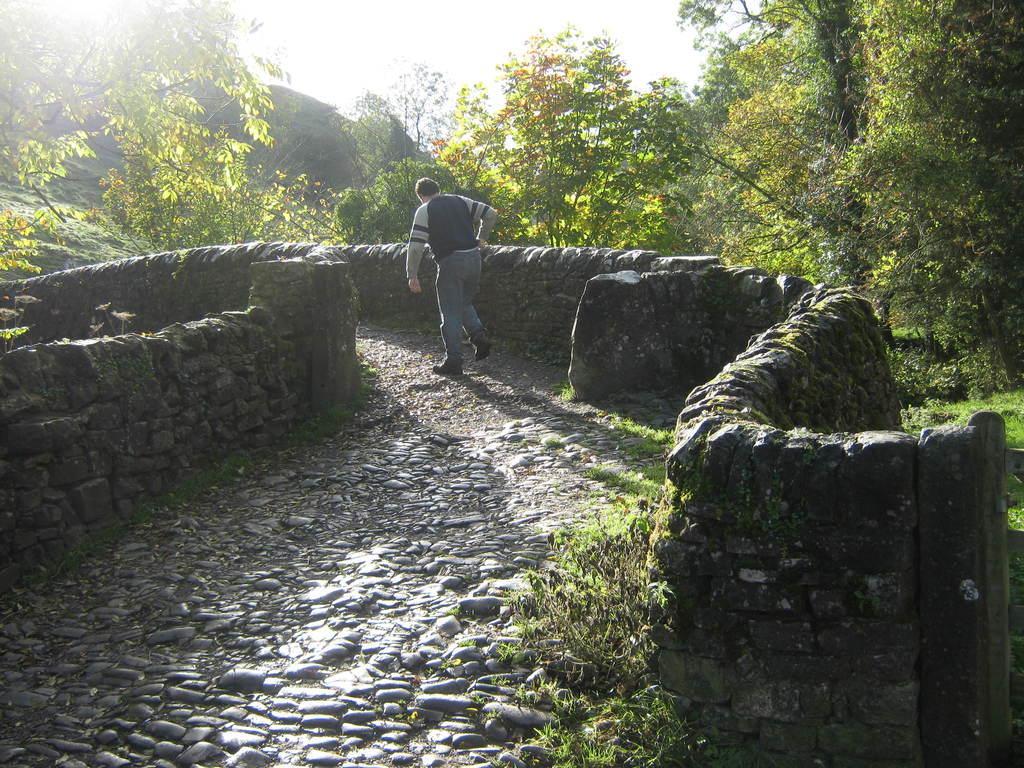Could you give a brief overview of what you see in this image? In this picture there is a man in the center of the image and there is pebbles floor in the center of the image, there are trees in the background area of the image. 